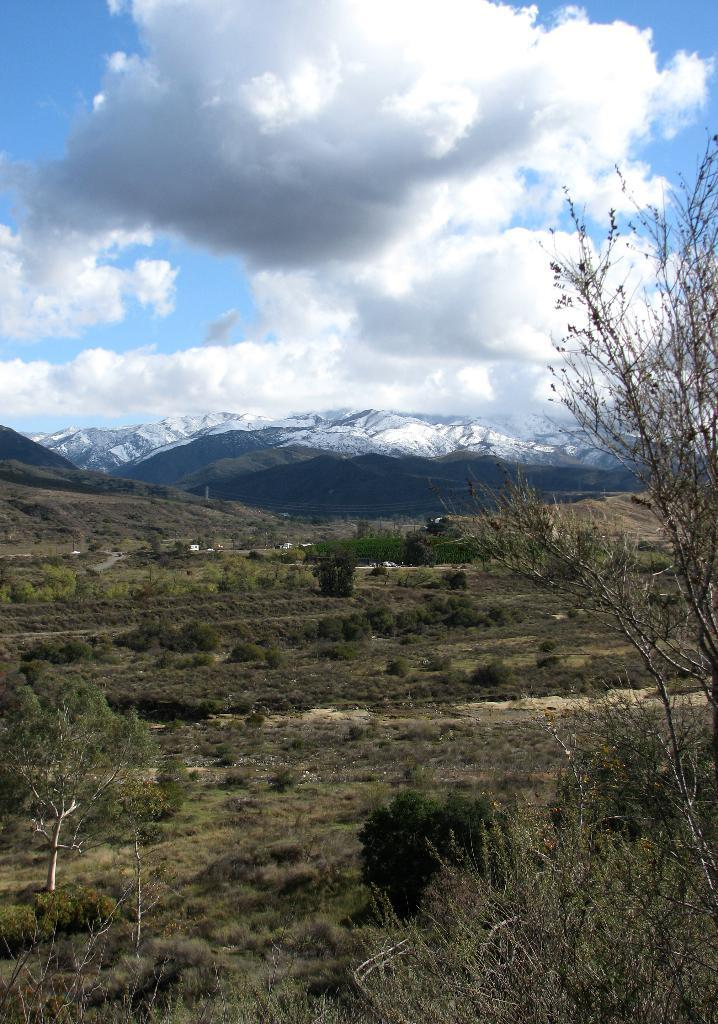What type of vegetation can be seen in the image? There are plants and trees visible in the image. What geographical features can be seen in the background of the image? There are hills visible in the background of the image. What is visible in the sky in the image? Clouds are present in the sky in the image. What type of riddle can be seen in the image? There is no riddle present in the image; it features plants, trees, hills, and clouds. Can you spot a bear interacting with the plants in the image? There is no bear present in the image; it only features plants, trees, hills, and clouds. 